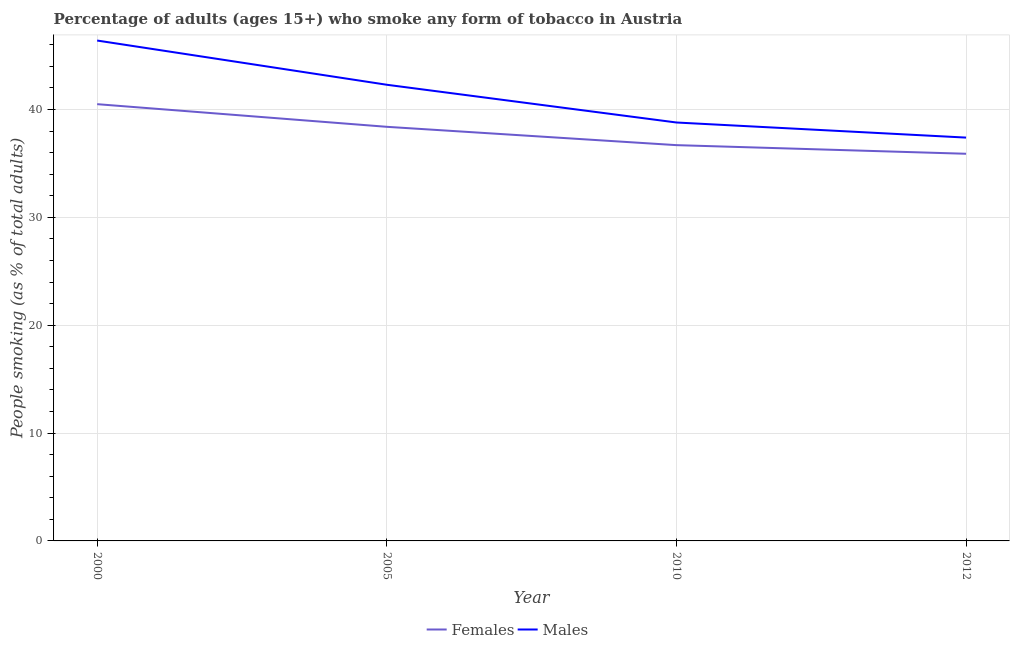Does the line corresponding to percentage of females who smoke intersect with the line corresponding to percentage of males who smoke?
Keep it short and to the point. No. Is the number of lines equal to the number of legend labels?
Your response must be concise. Yes. What is the percentage of males who smoke in 2005?
Offer a terse response. 42.3. Across all years, what is the maximum percentage of females who smoke?
Provide a short and direct response. 40.5. Across all years, what is the minimum percentage of males who smoke?
Your answer should be very brief. 37.4. In which year was the percentage of males who smoke maximum?
Your answer should be compact. 2000. What is the total percentage of females who smoke in the graph?
Make the answer very short. 151.5. What is the difference between the percentage of males who smoke in 2000 and that in 2010?
Provide a short and direct response. 7.6. What is the difference between the percentage of males who smoke in 2010 and the percentage of females who smoke in 2000?
Offer a very short reply. -1.7. What is the average percentage of males who smoke per year?
Your response must be concise. 41.22. In the year 2005, what is the difference between the percentage of females who smoke and percentage of males who smoke?
Keep it short and to the point. -3.9. What is the ratio of the percentage of females who smoke in 2005 to that in 2010?
Your response must be concise. 1.05. Is the percentage of females who smoke in 2005 less than that in 2010?
Your response must be concise. No. Is the difference between the percentage of females who smoke in 2000 and 2012 greater than the difference between the percentage of males who smoke in 2000 and 2012?
Keep it short and to the point. No. What is the difference between the highest and the second highest percentage of females who smoke?
Make the answer very short. 2.1. Does the percentage of females who smoke monotonically increase over the years?
Your answer should be compact. No. Is the percentage of males who smoke strictly less than the percentage of females who smoke over the years?
Provide a succinct answer. No. How many years are there in the graph?
Your answer should be very brief. 4. Are the values on the major ticks of Y-axis written in scientific E-notation?
Provide a succinct answer. No. Does the graph contain any zero values?
Provide a succinct answer. No. Does the graph contain grids?
Offer a terse response. Yes. Where does the legend appear in the graph?
Your response must be concise. Bottom center. What is the title of the graph?
Your answer should be compact. Percentage of adults (ages 15+) who smoke any form of tobacco in Austria. What is the label or title of the X-axis?
Give a very brief answer. Year. What is the label or title of the Y-axis?
Offer a terse response. People smoking (as % of total adults). What is the People smoking (as % of total adults) of Females in 2000?
Your answer should be very brief. 40.5. What is the People smoking (as % of total adults) of Males in 2000?
Keep it short and to the point. 46.4. What is the People smoking (as % of total adults) of Females in 2005?
Offer a very short reply. 38.4. What is the People smoking (as % of total adults) of Males in 2005?
Make the answer very short. 42.3. What is the People smoking (as % of total adults) in Females in 2010?
Make the answer very short. 36.7. What is the People smoking (as % of total adults) of Males in 2010?
Your answer should be very brief. 38.8. What is the People smoking (as % of total adults) of Females in 2012?
Your answer should be very brief. 35.9. What is the People smoking (as % of total adults) in Males in 2012?
Provide a short and direct response. 37.4. Across all years, what is the maximum People smoking (as % of total adults) in Females?
Keep it short and to the point. 40.5. Across all years, what is the maximum People smoking (as % of total adults) in Males?
Offer a very short reply. 46.4. Across all years, what is the minimum People smoking (as % of total adults) of Females?
Keep it short and to the point. 35.9. Across all years, what is the minimum People smoking (as % of total adults) in Males?
Keep it short and to the point. 37.4. What is the total People smoking (as % of total adults) in Females in the graph?
Offer a very short reply. 151.5. What is the total People smoking (as % of total adults) of Males in the graph?
Your answer should be compact. 164.9. What is the difference between the People smoking (as % of total adults) of Males in 2000 and that in 2005?
Your answer should be very brief. 4.1. What is the difference between the People smoking (as % of total adults) of Males in 2000 and that in 2010?
Offer a very short reply. 7.6. What is the difference between the People smoking (as % of total adults) of Males in 2000 and that in 2012?
Make the answer very short. 9. What is the difference between the People smoking (as % of total adults) in Males in 2005 and that in 2010?
Give a very brief answer. 3.5. What is the difference between the People smoking (as % of total adults) of Males in 2005 and that in 2012?
Your response must be concise. 4.9. What is the difference between the People smoking (as % of total adults) in Females in 2010 and that in 2012?
Your answer should be very brief. 0.8. What is the difference between the People smoking (as % of total adults) in Females in 2000 and the People smoking (as % of total adults) in Males in 2012?
Ensure brevity in your answer.  3.1. What is the difference between the People smoking (as % of total adults) of Females in 2005 and the People smoking (as % of total adults) of Males in 2012?
Your answer should be very brief. 1. What is the average People smoking (as % of total adults) in Females per year?
Provide a short and direct response. 37.88. What is the average People smoking (as % of total adults) of Males per year?
Offer a very short reply. 41.23. In the year 2000, what is the difference between the People smoking (as % of total adults) of Females and People smoking (as % of total adults) of Males?
Ensure brevity in your answer.  -5.9. In the year 2005, what is the difference between the People smoking (as % of total adults) of Females and People smoking (as % of total adults) of Males?
Offer a terse response. -3.9. In the year 2010, what is the difference between the People smoking (as % of total adults) in Females and People smoking (as % of total adults) in Males?
Offer a terse response. -2.1. In the year 2012, what is the difference between the People smoking (as % of total adults) in Females and People smoking (as % of total adults) in Males?
Provide a short and direct response. -1.5. What is the ratio of the People smoking (as % of total adults) of Females in 2000 to that in 2005?
Ensure brevity in your answer.  1.05. What is the ratio of the People smoking (as % of total adults) in Males in 2000 to that in 2005?
Make the answer very short. 1.1. What is the ratio of the People smoking (as % of total adults) of Females in 2000 to that in 2010?
Provide a short and direct response. 1.1. What is the ratio of the People smoking (as % of total adults) of Males in 2000 to that in 2010?
Offer a very short reply. 1.2. What is the ratio of the People smoking (as % of total adults) of Females in 2000 to that in 2012?
Ensure brevity in your answer.  1.13. What is the ratio of the People smoking (as % of total adults) of Males in 2000 to that in 2012?
Make the answer very short. 1.24. What is the ratio of the People smoking (as % of total adults) of Females in 2005 to that in 2010?
Offer a very short reply. 1.05. What is the ratio of the People smoking (as % of total adults) in Males in 2005 to that in 2010?
Give a very brief answer. 1.09. What is the ratio of the People smoking (as % of total adults) in Females in 2005 to that in 2012?
Ensure brevity in your answer.  1.07. What is the ratio of the People smoking (as % of total adults) in Males in 2005 to that in 2012?
Ensure brevity in your answer.  1.13. What is the ratio of the People smoking (as % of total adults) in Females in 2010 to that in 2012?
Offer a terse response. 1.02. What is the ratio of the People smoking (as % of total adults) in Males in 2010 to that in 2012?
Ensure brevity in your answer.  1.04. What is the difference between the highest and the second highest People smoking (as % of total adults) in Females?
Your answer should be compact. 2.1. What is the difference between the highest and the second highest People smoking (as % of total adults) of Males?
Keep it short and to the point. 4.1. 